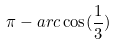Convert formula to latex. <formula><loc_0><loc_0><loc_500><loc_500>\pi - a r c \cos ( \frac { 1 } { 3 } )</formula> 